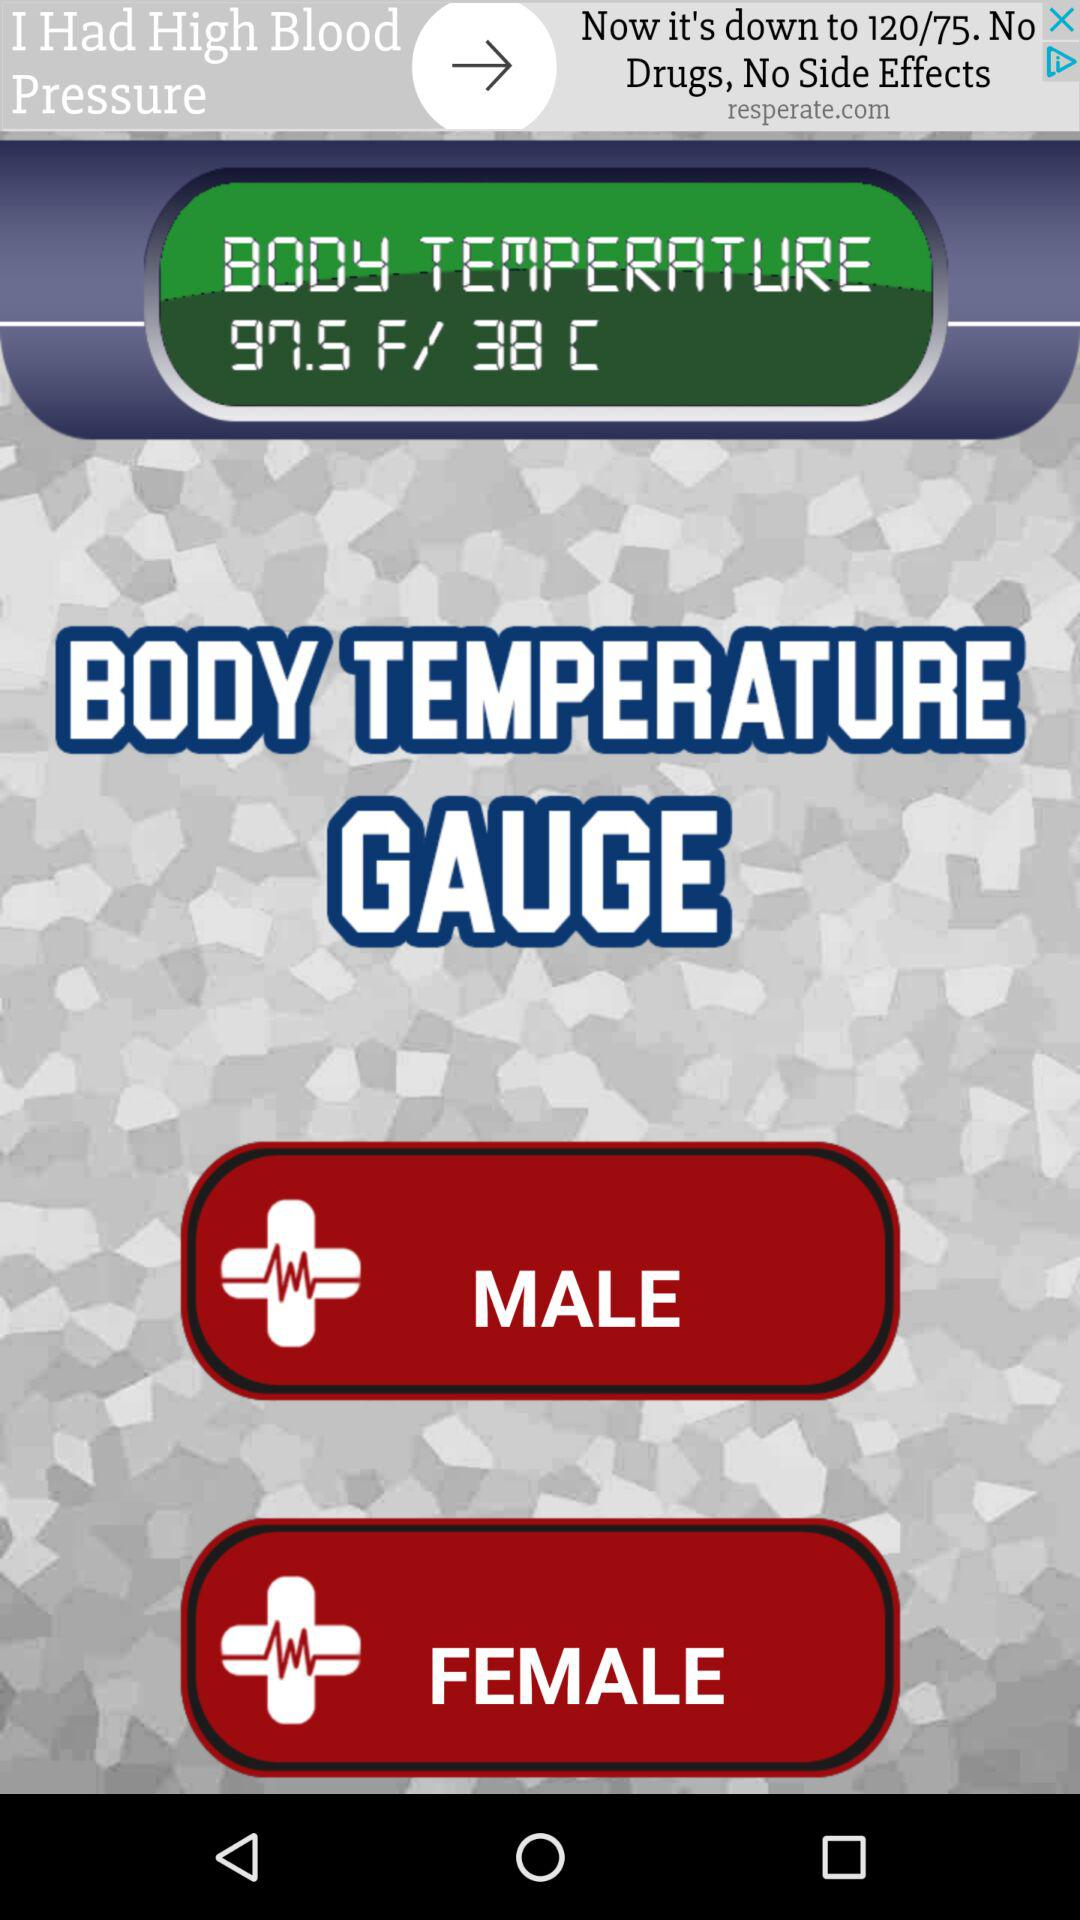What is the body temperature? The body temperature is 97.5 F/ 38 C. 